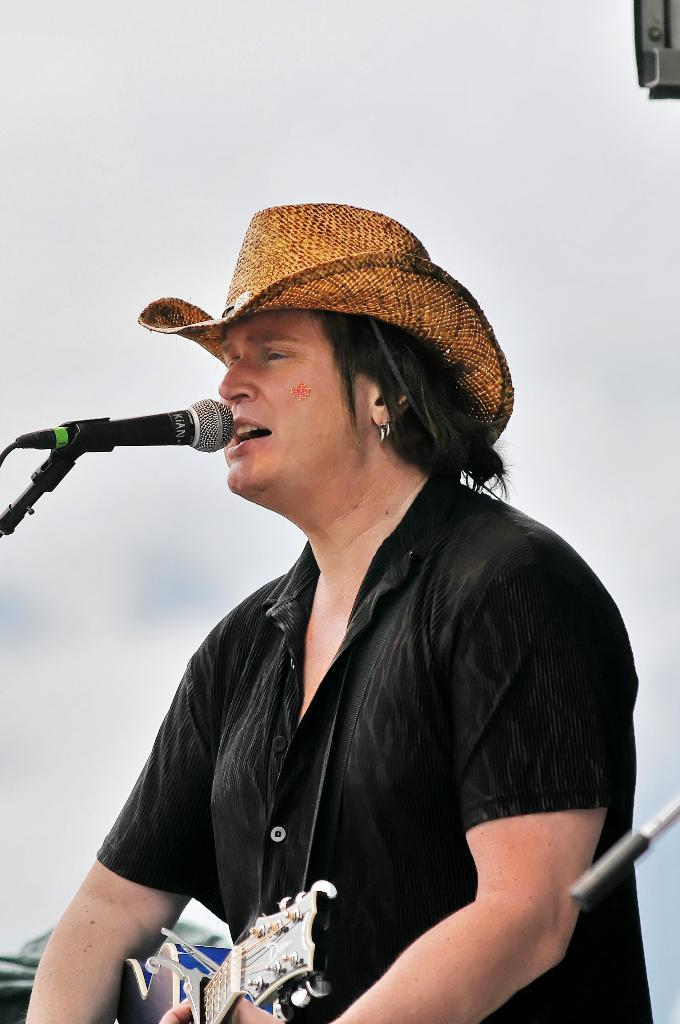What is the person in the image doing? The person is holding a guitar and there is a microphone in front of them, so they might be performing or about to perform. What is the person wearing on their head? The person is wearing a hat. What color is the shirt the person is wearing? The person is wearing a black shirt. What can be seen in the background of the image? There is a wall in the background of the image. How many books are visible on the wall in the image? There are no books visible on the wall in the image. 